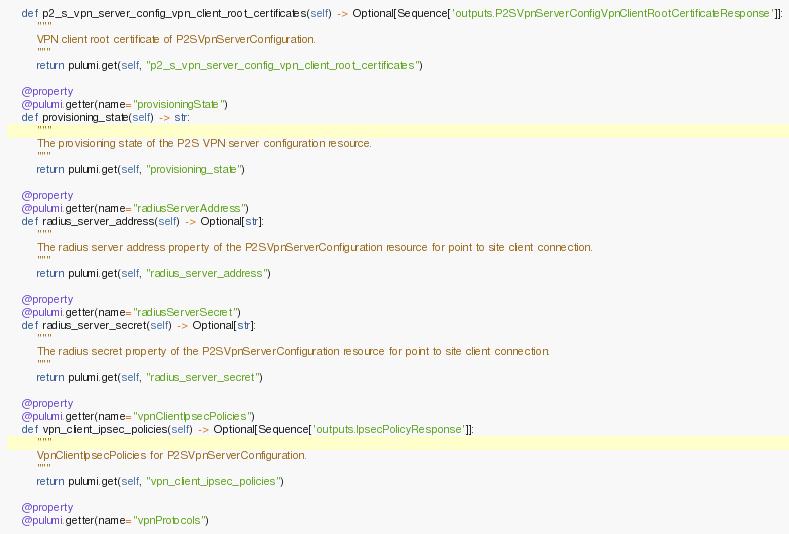Convert code to text. <code><loc_0><loc_0><loc_500><loc_500><_Python_>    def p2_s_vpn_server_config_vpn_client_root_certificates(self) -> Optional[Sequence['outputs.P2SVpnServerConfigVpnClientRootCertificateResponse']]:
        """
        VPN client root certificate of P2SVpnServerConfiguration.
        """
        return pulumi.get(self, "p2_s_vpn_server_config_vpn_client_root_certificates")

    @property
    @pulumi.getter(name="provisioningState")
    def provisioning_state(self) -> str:
        """
        The provisioning state of the P2S VPN server configuration resource.
        """
        return pulumi.get(self, "provisioning_state")

    @property
    @pulumi.getter(name="radiusServerAddress")
    def radius_server_address(self) -> Optional[str]:
        """
        The radius server address property of the P2SVpnServerConfiguration resource for point to site client connection.
        """
        return pulumi.get(self, "radius_server_address")

    @property
    @pulumi.getter(name="radiusServerSecret")
    def radius_server_secret(self) -> Optional[str]:
        """
        The radius secret property of the P2SVpnServerConfiguration resource for point to site client connection.
        """
        return pulumi.get(self, "radius_server_secret")

    @property
    @pulumi.getter(name="vpnClientIpsecPolicies")
    def vpn_client_ipsec_policies(self) -> Optional[Sequence['outputs.IpsecPolicyResponse']]:
        """
        VpnClientIpsecPolicies for P2SVpnServerConfiguration.
        """
        return pulumi.get(self, "vpn_client_ipsec_policies")

    @property
    @pulumi.getter(name="vpnProtocols")</code> 